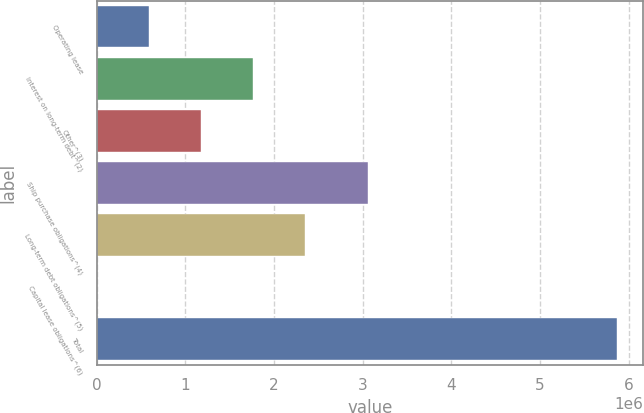Convert chart to OTSL. <chart><loc_0><loc_0><loc_500><loc_500><bar_chart><fcel>Operating lease<fcel>Interest on long-term debt^(2)<fcel>Other^(3)<fcel>Ship purchase obligations^(4)<fcel>Long-term debt obligations^(5)<fcel>Capital lease obligations^(6)<fcel>Total<nl><fcel>593612<fcel>1.76642e+06<fcel>1.18002e+06<fcel>3.06316e+06<fcel>2.35282e+06<fcel>7210<fcel>5.87124e+06<nl></chart> 